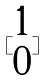<formula> <loc_0><loc_0><loc_500><loc_500>[ \begin{matrix} 1 \\ 0 \end{matrix} ]</formula> 